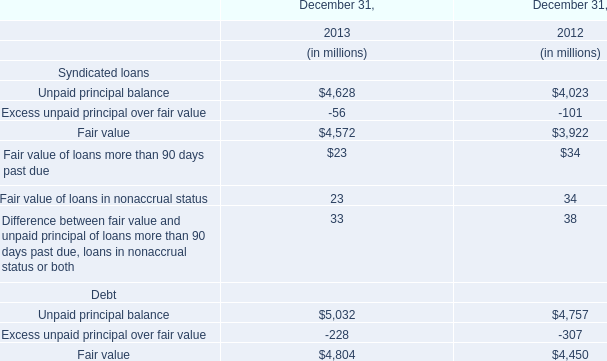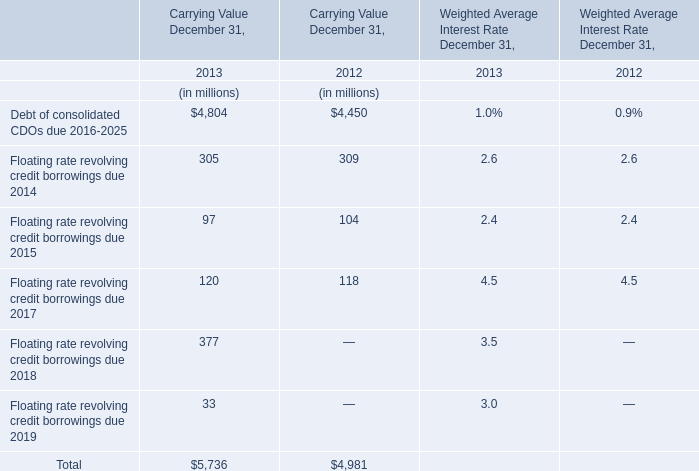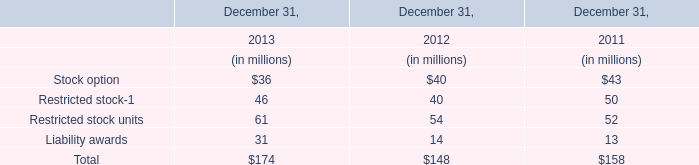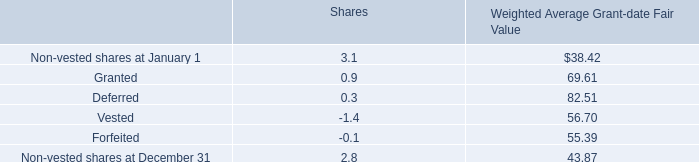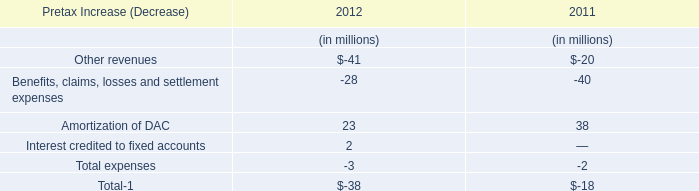What's the average of Unpaid principal balance of Debt in 2013 and 2012? (in million) 
Computations: ((5032 + 4757) / 2)
Answer: 4894.5. 